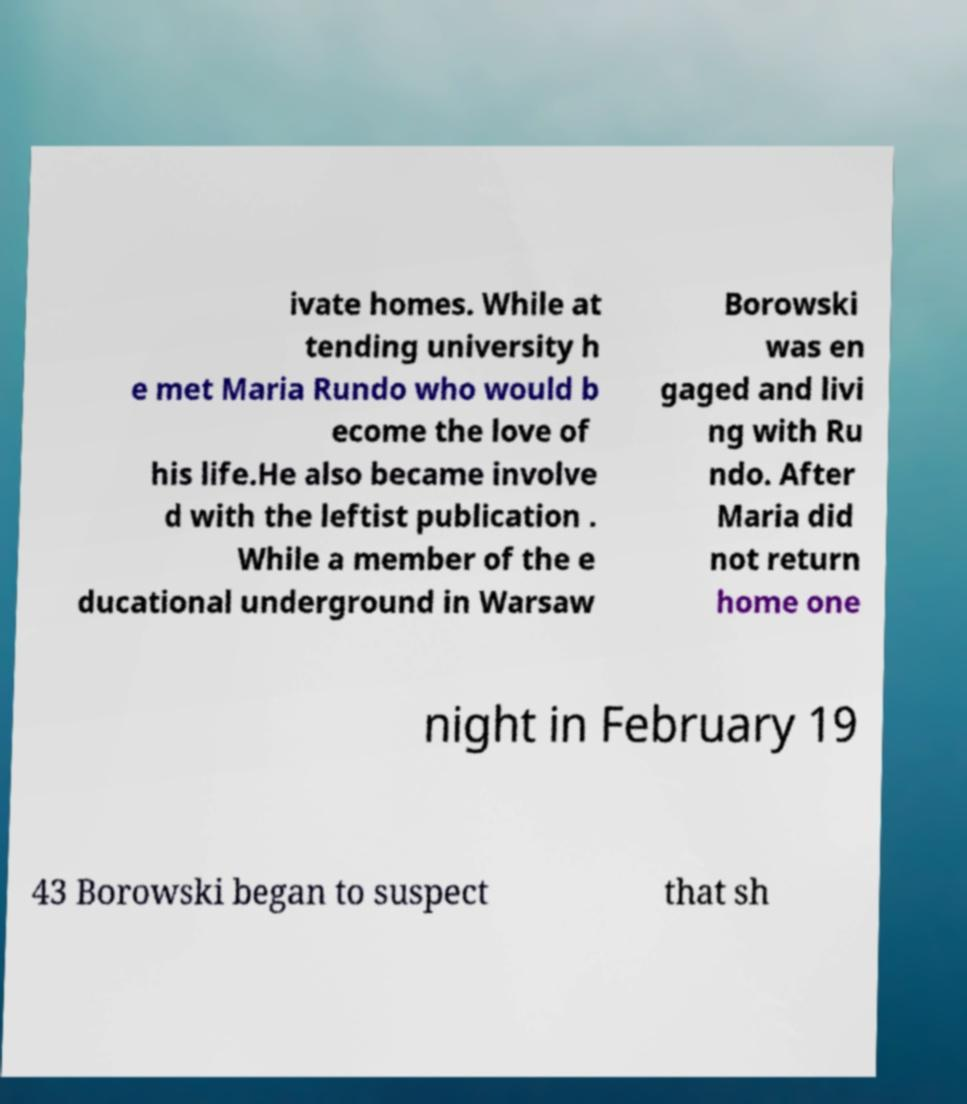What messages or text are displayed in this image? I need them in a readable, typed format. ivate homes. While at tending university h e met Maria Rundo who would b ecome the love of his life.He also became involve d with the leftist publication . While a member of the e ducational underground in Warsaw Borowski was en gaged and livi ng with Ru ndo. After Maria did not return home one night in February 19 43 Borowski began to suspect that sh 